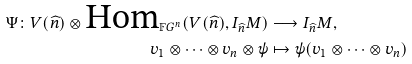Convert formula to latex. <formula><loc_0><loc_0><loc_500><loc_500>\Psi \colon V ( \widehat { n } ) \otimes \text {Hom} _ { \mathbb { F } G ^ { n } } ( V ( \widehat { n } ) , I _ { \widehat { n } } M ) & \longrightarrow I _ { \widehat { n } } M , \\ v _ { 1 } \otimes \cdots \otimes v _ { n } \otimes \psi & \mapsto \psi ( v _ { 1 } \otimes \cdots \otimes v _ { n } )</formula> 